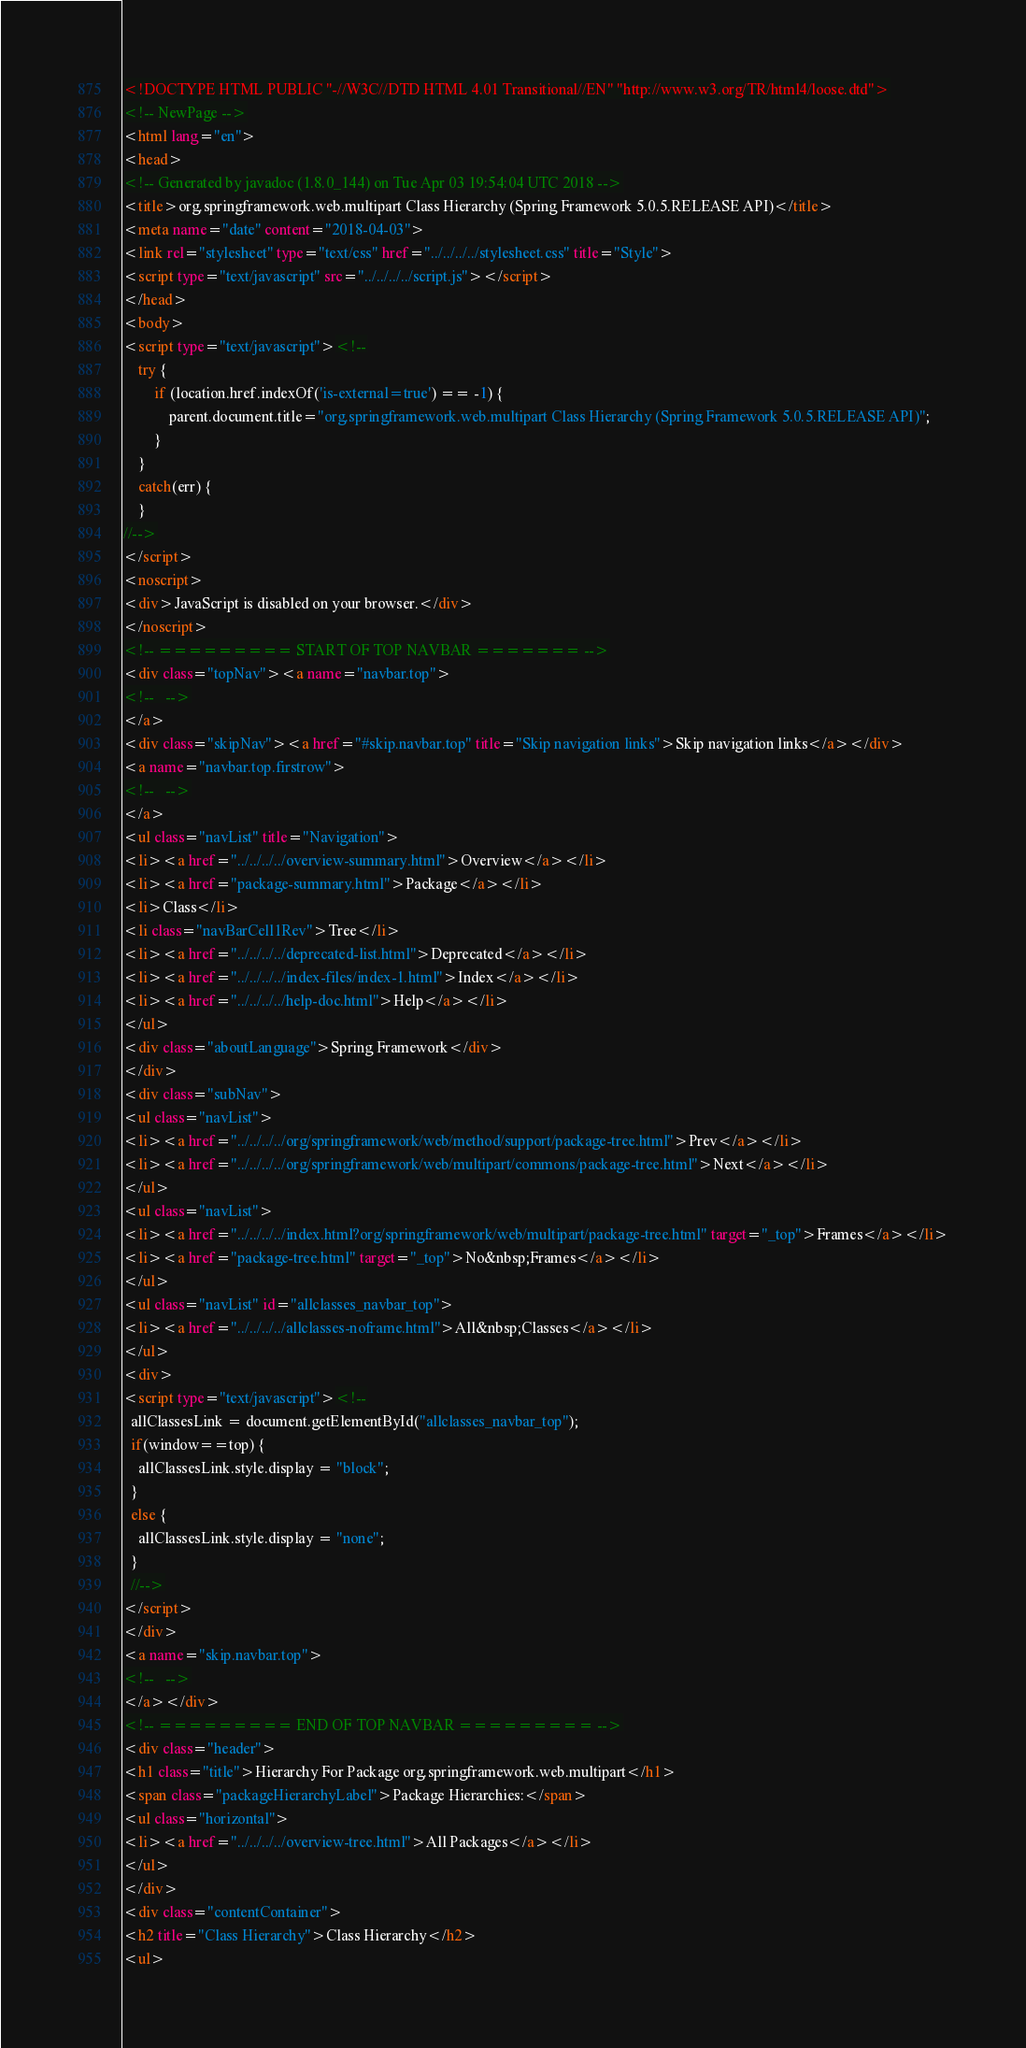<code> <loc_0><loc_0><loc_500><loc_500><_HTML_><!DOCTYPE HTML PUBLIC "-//W3C//DTD HTML 4.01 Transitional//EN" "http://www.w3.org/TR/html4/loose.dtd">
<!-- NewPage -->
<html lang="en">
<head>
<!-- Generated by javadoc (1.8.0_144) on Tue Apr 03 19:54:04 UTC 2018 -->
<title>org.springframework.web.multipart Class Hierarchy (Spring Framework 5.0.5.RELEASE API)</title>
<meta name="date" content="2018-04-03">
<link rel="stylesheet" type="text/css" href="../../../../stylesheet.css" title="Style">
<script type="text/javascript" src="../../../../script.js"></script>
</head>
<body>
<script type="text/javascript"><!--
    try {
        if (location.href.indexOf('is-external=true') == -1) {
            parent.document.title="org.springframework.web.multipart Class Hierarchy (Spring Framework 5.0.5.RELEASE API)";
        }
    }
    catch(err) {
    }
//-->
</script>
<noscript>
<div>JavaScript is disabled on your browser.</div>
</noscript>
<!-- ========= START OF TOP NAVBAR ======= -->
<div class="topNav"><a name="navbar.top">
<!--   -->
</a>
<div class="skipNav"><a href="#skip.navbar.top" title="Skip navigation links">Skip navigation links</a></div>
<a name="navbar.top.firstrow">
<!--   -->
</a>
<ul class="navList" title="Navigation">
<li><a href="../../../../overview-summary.html">Overview</a></li>
<li><a href="package-summary.html">Package</a></li>
<li>Class</li>
<li class="navBarCell1Rev">Tree</li>
<li><a href="../../../../deprecated-list.html">Deprecated</a></li>
<li><a href="../../../../index-files/index-1.html">Index</a></li>
<li><a href="../../../../help-doc.html">Help</a></li>
</ul>
<div class="aboutLanguage">Spring Framework</div>
</div>
<div class="subNav">
<ul class="navList">
<li><a href="../../../../org/springframework/web/method/support/package-tree.html">Prev</a></li>
<li><a href="../../../../org/springframework/web/multipart/commons/package-tree.html">Next</a></li>
</ul>
<ul class="navList">
<li><a href="../../../../index.html?org/springframework/web/multipart/package-tree.html" target="_top">Frames</a></li>
<li><a href="package-tree.html" target="_top">No&nbsp;Frames</a></li>
</ul>
<ul class="navList" id="allclasses_navbar_top">
<li><a href="../../../../allclasses-noframe.html">All&nbsp;Classes</a></li>
</ul>
<div>
<script type="text/javascript"><!--
  allClassesLink = document.getElementById("allclasses_navbar_top");
  if(window==top) {
    allClassesLink.style.display = "block";
  }
  else {
    allClassesLink.style.display = "none";
  }
  //-->
</script>
</div>
<a name="skip.navbar.top">
<!--   -->
</a></div>
<!-- ========= END OF TOP NAVBAR ========= -->
<div class="header">
<h1 class="title">Hierarchy For Package org.springframework.web.multipart</h1>
<span class="packageHierarchyLabel">Package Hierarchies:</span>
<ul class="horizontal">
<li><a href="../../../../overview-tree.html">All Packages</a></li>
</ul>
</div>
<div class="contentContainer">
<h2 title="Class Hierarchy">Class Hierarchy</h2>
<ul></code> 